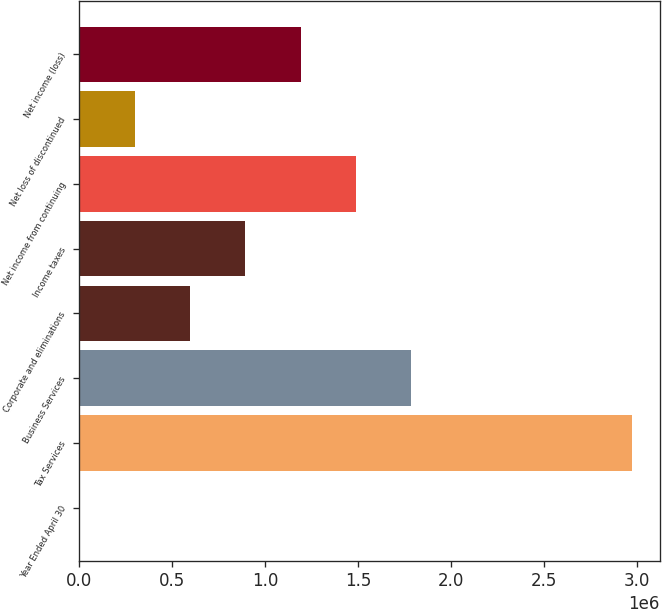Convert chart. <chart><loc_0><loc_0><loc_500><loc_500><bar_chart><fcel>Year Ended April 30<fcel>Tax Services<fcel>Business Services<fcel>Corporate and eliminations<fcel>Income taxes<fcel>Net income from continuing<fcel>Net loss of discontinued<fcel>Net income (loss)<nl><fcel>2010<fcel>2.97525e+06<fcel>1.78596e+06<fcel>596658<fcel>893983<fcel>1.48863e+06<fcel>299334<fcel>1.19131e+06<nl></chart> 